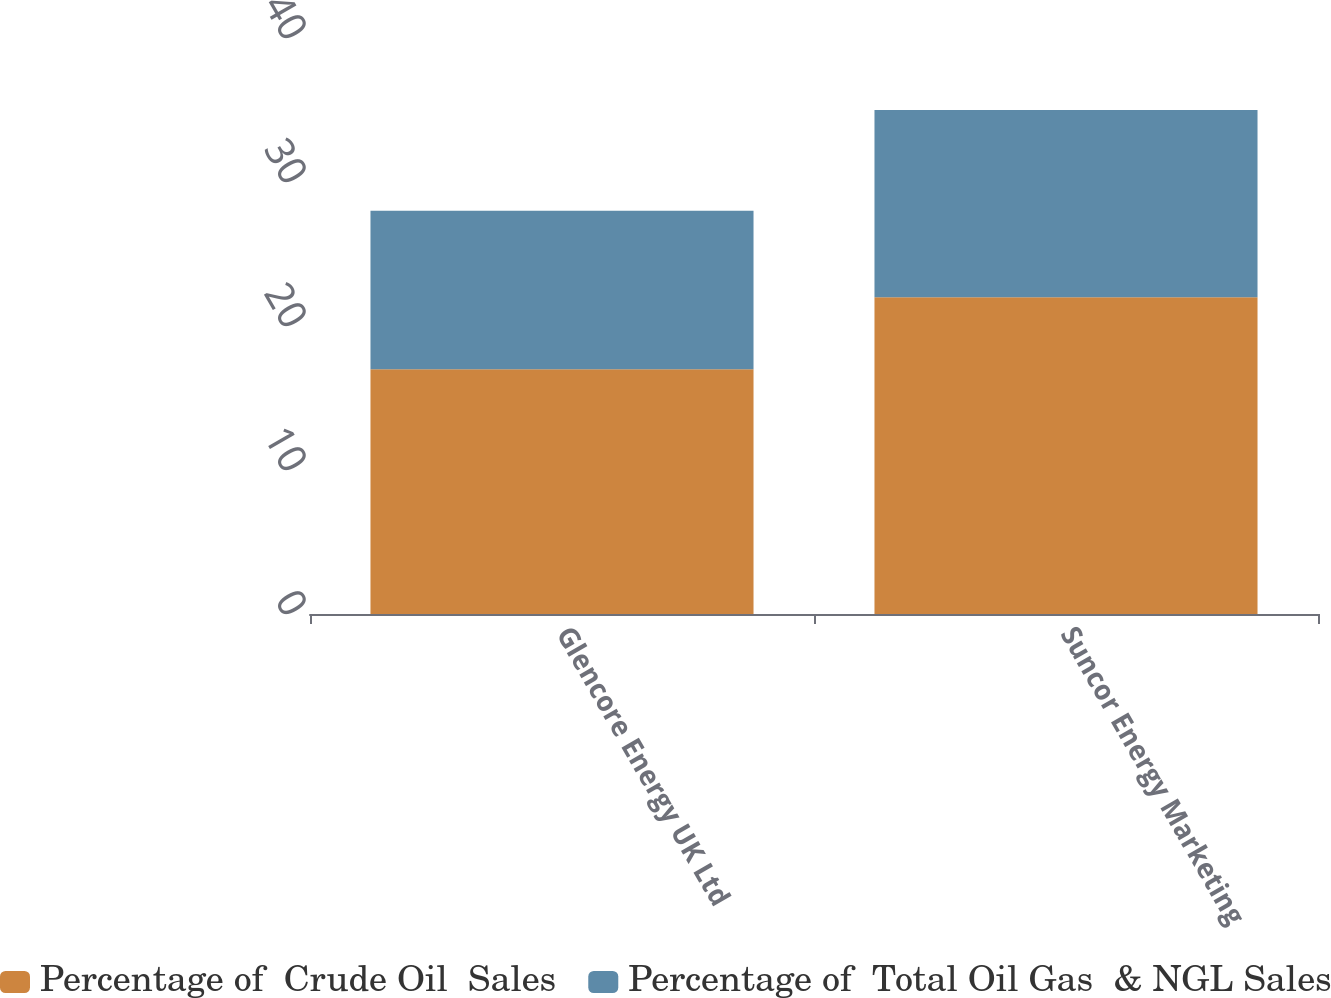<chart> <loc_0><loc_0><loc_500><loc_500><stacked_bar_chart><ecel><fcel>Glencore Energy UK Ltd<fcel>Suncor Energy Marketing<nl><fcel>Percentage of  Crude Oil  Sales<fcel>17<fcel>22<nl><fcel>Percentage of  Total Oil Gas  & NGL Sales<fcel>11<fcel>13<nl></chart> 